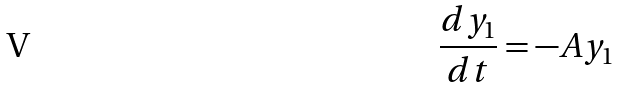<formula> <loc_0><loc_0><loc_500><loc_500>\frac { d y _ { 1 } } { d t } = - A y _ { 1 }</formula> 